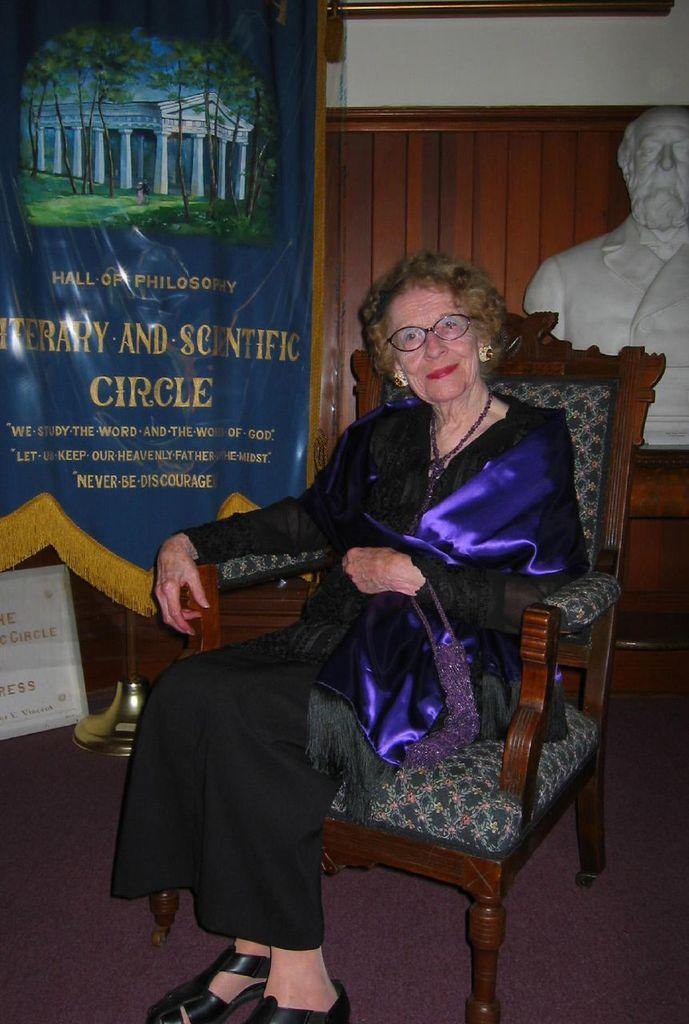Who is present in the image? There is a woman in the image. What is the woman doing in the image? The woman is seated on a chair. What can be seen in the background of the image? There is a statue and a hoarding in the background of the image. What type of yam is the scarecrow holding in the image? There is no scarecrow or yam present in the image. 